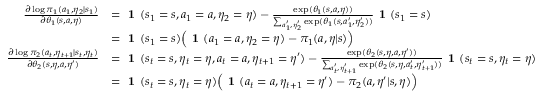<formula> <loc_0><loc_0><loc_500><loc_500>\begin{array} { r l } { \frac { \partial \log \pi _ { 1 } ( a _ { 1 } , \eta _ { 2 } | s _ { 1 } ) } { \partial \theta _ { 1 } ( s , a , \eta ) } } & { = 1 ( s _ { 1 } = s , a _ { 1 } = a , \eta _ { 2 } = \eta ) - \frac { \exp ( \theta _ { 1 } ( s , a , \eta ) ) } { \sum _ { a _ { 1 } ^ { \prime } , \eta _ { 2 } ^ { \prime } } \exp ( \theta _ { 1 } ( s , a _ { 1 } ^ { \prime } , \eta _ { 2 } ^ { \prime } ) ) } 1 ( s _ { 1 } = s ) } \\ & { = 1 ( s _ { 1 } = s ) \left ( 1 ( a _ { 1 } = a , \eta _ { 2 } = \eta ) - \pi _ { 1 } ( a , \eta | s ) \right ) } \\ { \frac { \partial \log \pi _ { 2 } ( a _ { t } , \eta _ { t + 1 } | s _ { t } , \eta _ { t } ) } { \partial \theta _ { 2 } ( s , \eta , a , \eta ^ { \prime } ) } } & { = 1 ( s _ { t } = s , \eta _ { t } = \eta , a _ { t } = a , \eta _ { t + 1 } = \eta ^ { \prime } ) - \frac { \exp ( \theta _ { 2 } ( s , \eta , a , \eta ^ { \prime } ) ) } { \sum _ { a _ { t } ^ { \prime } , \eta _ { t + 1 } ^ { \prime } } \exp ( \theta _ { 2 } ( s , \eta , a _ { t } ^ { \prime } , \eta _ { t + 1 } ^ { \prime } ) ) } 1 ( s _ { t } = s , \eta _ { t } = \eta ) } \\ & { = 1 ( s _ { t } = s , \eta _ { t } = \eta ) \left ( 1 ( a _ { t } = a , \eta _ { t + 1 } = \eta ^ { \prime } ) - \pi _ { 2 } ( a , \eta ^ { \prime } | s , \eta ) \right ) } \end{array}</formula> 